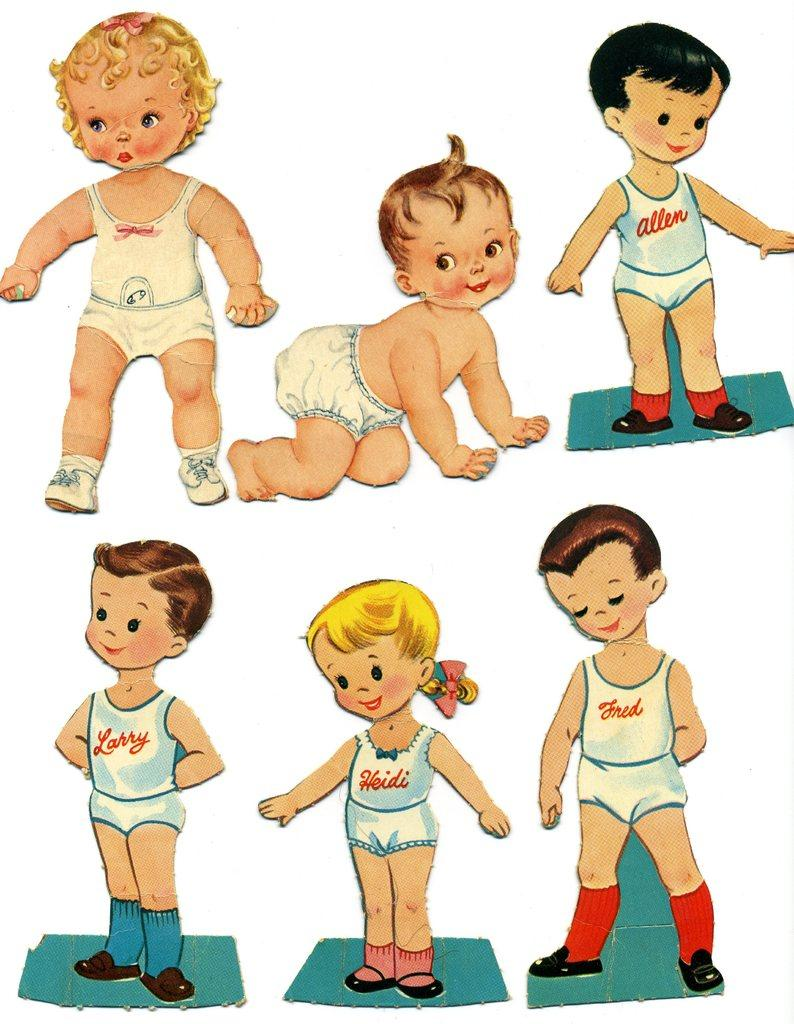How many children are present in the image? There are six kids in the image. Can you describe the position of the kids in the image? The kids may be on the floor, but the exact position is not clear. What can be inferred about the image based on the provided fact? The image appears to be an edited photo. What type of pickle is being used as a pillow by one of the kids in the image? There is no pickle present in the image, and the kids are not using any objects as pillows. 